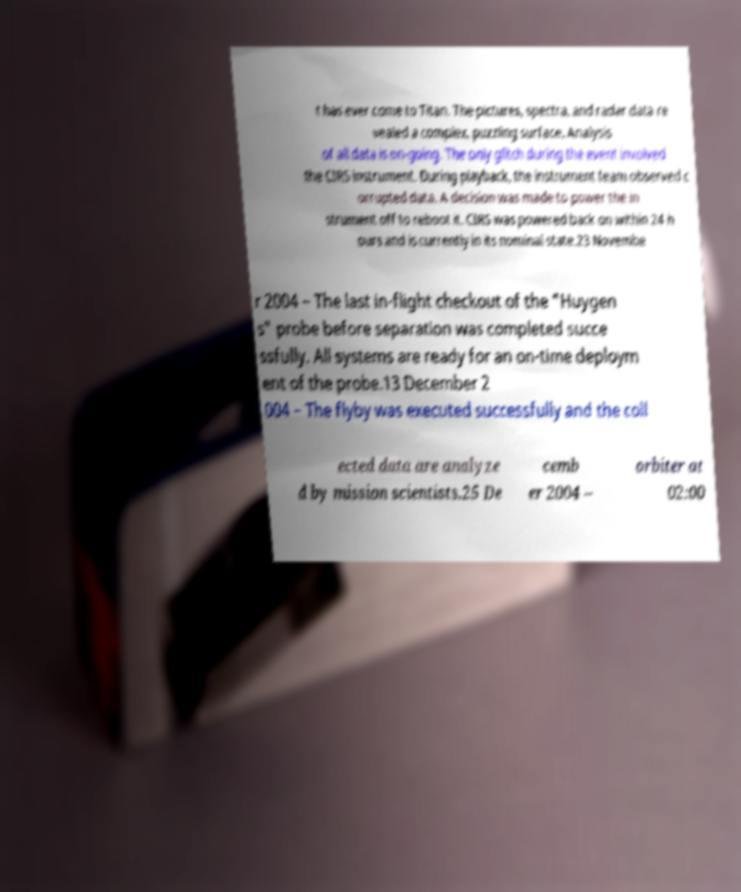I need the written content from this picture converted into text. Can you do that? t has ever come to Titan. The pictures, spectra, and radar data re vealed a complex, puzzling surface. Analysis of all data is on-going. The only glitch during the event involved the CIRS instrument. During playback, the instrument team observed c orrupted data. A decision was made to power the in strument off to reboot it. CIRS was powered back on within 24 h ours and is currently in its nominal state.23 Novembe r 2004 – The last in-flight checkout of the "Huygen s" probe before separation was completed succe ssfully. All systems are ready for an on-time deploym ent of the probe.13 December 2 004 – The flyby was executed successfully and the coll ected data are analyze d by mission scientists.25 De cemb er 2004 – orbiter at 02:00 